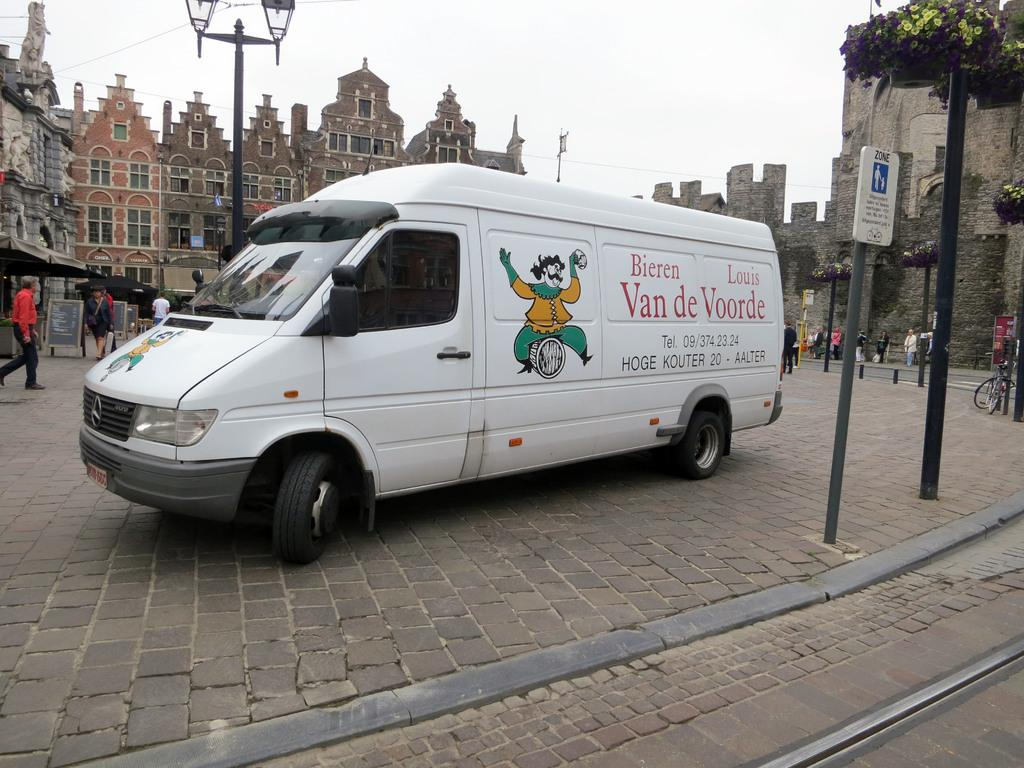<image>
Write a terse but informative summary of the picture. a Bieren Louis Van de Voorde parked on a cobblestone road 